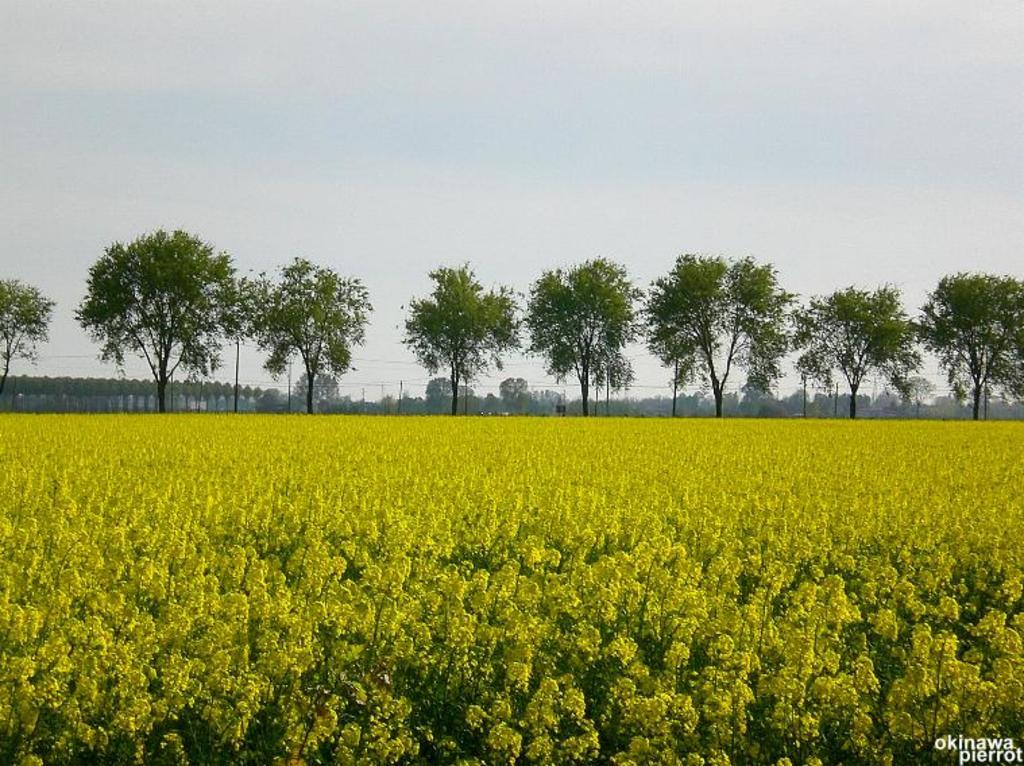What type of plants can be seen in the image? There are plants with flowers in the image. What other natural elements are present in the image? There are trees in the image. What man-made objects can be seen in the image? There are poles in the image. What is visible in the background of the image? The sky is visible in the image. How does the rake appear in the image? There is no rake present in the image. 